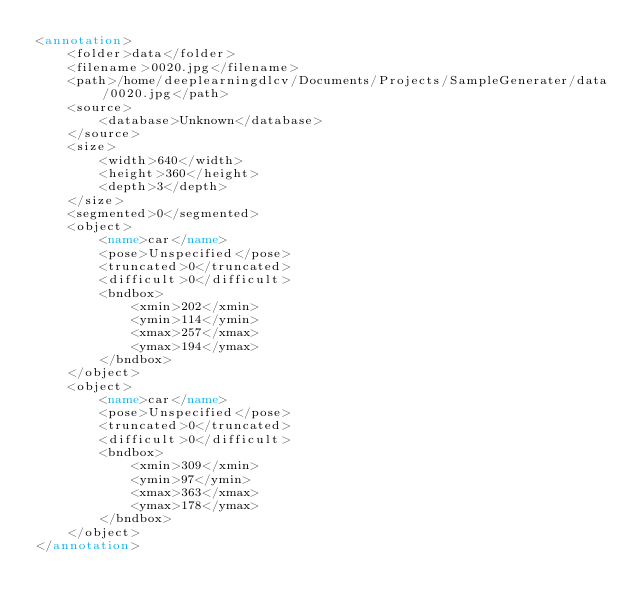Convert code to text. <code><loc_0><loc_0><loc_500><loc_500><_XML_><annotation>
	<folder>data</folder>
	<filename>0020.jpg</filename>
	<path>/home/deeplearningdlcv/Documents/Projects/SampleGenerater/data/0020.jpg</path>
	<source>
		<database>Unknown</database>
	</source>
	<size>
		<width>640</width>
		<height>360</height>
		<depth>3</depth>
	</size>
	<segmented>0</segmented>
	<object>
		<name>car</name>
		<pose>Unspecified</pose>
		<truncated>0</truncated>
		<difficult>0</difficult>
		<bndbox>
			<xmin>202</xmin>
			<ymin>114</ymin>
			<xmax>257</xmax>
			<ymax>194</ymax>
		</bndbox>
	</object>
	<object>
		<name>car</name>
		<pose>Unspecified</pose>
		<truncated>0</truncated>
		<difficult>0</difficult>
		<bndbox>
			<xmin>309</xmin>
			<ymin>97</ymin>
			<xmax>363</xmax>
			<ymax>178</ymax>
		</bndbox>
	</object>
</annotation>
</code> 